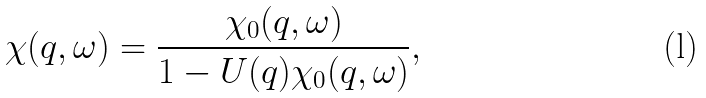<formula> <loc_0><loc_0><loc_500><loc_500>\chi ( { q } , \omega ) = \frac { \chi _ { 0 } ( { q } , \omega ) } { 1 - U ( { q } ) \chi _ { 0 } ( { q } , \omega ) } ,</formula> 